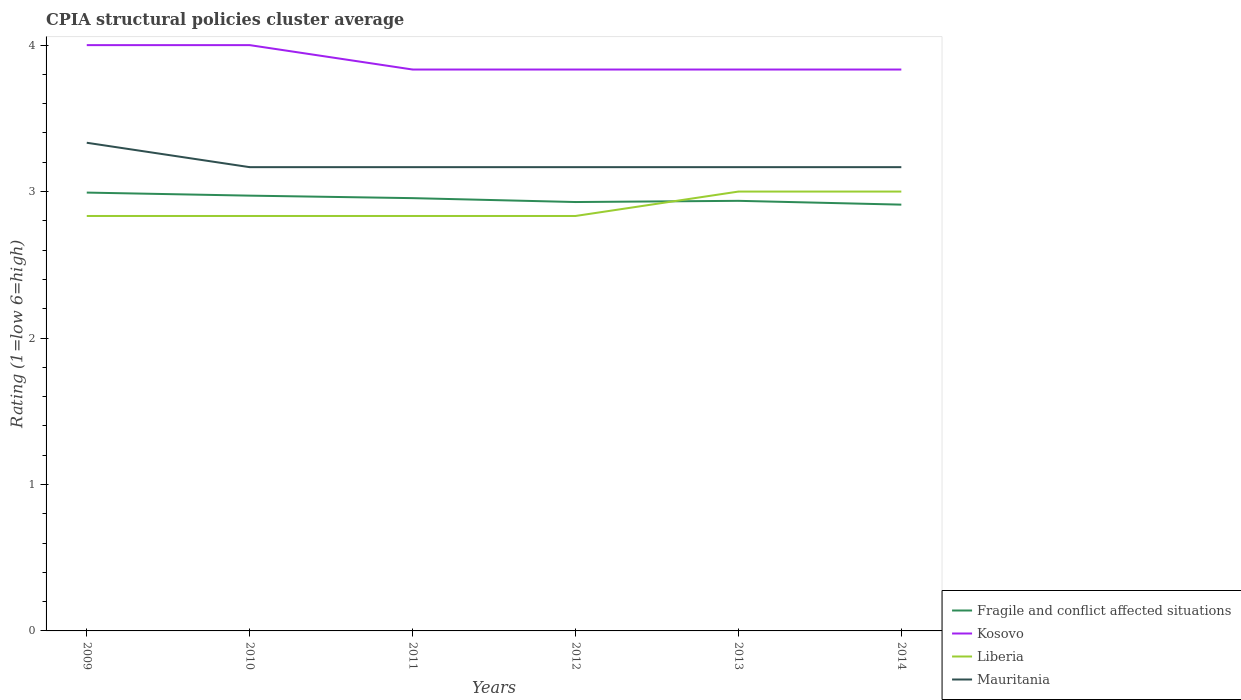How many different coloured lines are there?
Offer a terse response. 4. Does the line corresponding to Fragile and conflict affected situations intersect with the line corresponding to Kosovo?
Ensure brevity in your answer.  No. Is the number of lines equal to the number of legend labels?
Your answer should be compact. Yes. Across all years, what is the maximum CPIA rating in Liberia?
Your response must be concise. 2.83. In which year was the CPIA rating in Kosovo maximum?
Your answer should be compact. 2014. What is the total CPIA rating in Kosovo in the graph?
Keep it short and to the point. 0. What is the difference between the highest and the second highest CPIA rating in Fragile and conflict affected situations?
Offer a terse response. 0.08. What is the difference between the highest and the lowest CPIA rating in Fragile and conflict affected situations?
Provide a succinct answer. 3. Is the CPIA rating in Kosovo strictly greater than the CPIA rating in Fragile and conflict affected situations over the years?
Ensure brevity in your answer.  No. How many lines are there?
Offer a terse response. 4. What is the difference between two consecutive major ticks on the Y-axis?
Offer a terse response. 1. Where does the legend appear in the graph?
Make the answer very short. Bottom right. How are the legend labels stacked?
Give a very brief answer. Vertical. What is the title of the graph?
Offer a terse response. CPIA structural policies cluster average. Does "Low income" appear as one of the legend labels in the graph?
Make the answer very short. No. What is the label or title of the X-axis?
Your answer should be compact. Years. What is the Rating (1=low 6=high) in Fragile and conflict affected situations in 2009?
Make the answer very short. 2.99. What is the Rating (1=low 6=high) in Liberia in 2009?
Give a very brief answer. 2.83. What is the Rating (1=low 6=high) in Mauritania in 2009?
Keep it short and to the point. 3.33. What is the Rating (1=low 6=high) in Fragile and conflict affected situations in 2010?
Offer a very short reply. 2.97. What is the Rating (1=low 6=high) in Kosovo in 2010?
Provide a succinct answer. 4. What is the Rating (1=low 6=high) of Liberia in 2010?
Your response must be concise. 2.83. What is the Rating (1=low 6=high) of Mauritania in 2010?
Give a very brief answer. 3.17. What is the Rating (1=low 6=high) in Fragile and conflict affected situations in 2011?
Your answer should be compact. 2.96. What is the Rating (1=low 6=high) in Kosovo in 2011?
Give a very brief answer. 3.83. What is the Rating (1=low 6=high) of Liberia in 2011?
Your response must be concise. 2.83. What is the Rating (1=low 6=high) of Mauritania in 2011?
Make the answer very short. 3.17. What is the Rating (1=low 6=high) of Fragile and conflict affected situations in 2012?
Your response must be concise. 2.93. What is the Rating (1=low 6=high) of Kosovo in 2012?
Make the answer very short. 3.83. What is the Rating (1=low 6=high) in Liberia in 2012?
Your answer should be very brief. 2.83. What is the Rating (1=low 6=high) in Mauritania in 2012?
Ensure brevity in your answer.  3.17. What is the Rating (1=low 6=high) of Fragile and conflict affected situations in 2013?
Keep it short and to the point. 2.94. What is the Rating (1=low 6=high) of Kosovo in 2013?
Offer a very short reply. 3.83. What is the Rating (1=low 6=high) of Liberia in 2013?
Your answer should be very brief. 3. What is the Rating (1=low 6=high) of Mauritania in 2013?
Keep it short and to the point. 3.17. What is the Rating (1=low 6=high) of Fragile and conflict affected situations in 2014?
Keep it short and to the point. 2.91. What is the Rating (1=low 6=high) of Kosovo in 2014?
Make the answer very short. 3.83. What is the Rating (1=low 6=high) of Liberia in 2014?
Provide a short and direct response. 3. What is the Rating (1=low 6=high) of Mauritania in 2014?
Keep it short and to the point. 3.17. Across all years, what is the maximum Rating (1=low 6=high) of Fragile and conflict affected situations?
Your answer should be very brief. 2.99. Across all years, what is the maximum Rating (1=low 6=high) in Kosovo?
Offer a terse response. 4. Across all years, what is the maximum Rating (1=low 6=high) in Liberia?
Provide a succinct answer. 3. Across all years, what is the maximum Rating (1=low 6=high) in Mauritania?
Keep it short and to the point. 3.33. Across all years, what is the minimum Rating (1=low 6=high) in Fragile and conflict affected situations?
Provide a short and direct response. 2.91. Across all years, what is the minimum Rating (1=low 6=high) of Kosovo?
Your response must be concise. 3.83. Across all years, what is the minimum Rating (1=low 6=high) of Liberia?
Offer a terse response. 2.83. Across all years, what is the minimum Rating (1=low 6=high) in Mauritania?
Provide a succinct answer. 3.17. What is the total Rating (1=low 6=high) of Fragile and conflict affected situations in the graph?
Provide a succinct answer. 17.7. What is the total Rating (1=low 6=high) in Kosovo in the graph?
Offer a very short reply. 23.33. What is the total Rating (1=low 6=high) of Liberia in the graph?
Your answer should be compact. 17.33. What is the total Rating (1=low 6=high) of Mauritania in the graph?
Your answer should be compact. 19.17. What is the difference between the Rating (1=low 6=high) of Fragile and conflict affected situations in 2009 and that in 2010?
Offer a very short reply. 0.02. What is the difference between the Rating (1=low 6=high) in Mauritania in 2009 and that in 2010?
Ensure brevity in your answer.  0.17. What is the difference between the Rating (1=low 6=high) in Fragile and conflict affected situations in 2009 and that in 2011?
Keep it short and to the point. 0.04. What is the difference between the Rating (1=low 6=high) of Kosovo in 2009 and that in 2011?
Offer a very short reply. 0.17. What is the difference between the Rating (1=low 6=high) of Liberia in 2009 and that in 2011?
Give a very brief answer. 0. What is the difference between the Rating (1=low 6=high) of Mauritania in 2009 and that in 2011?
Give a very brief answer. 0.17. What is the difference between the Rating (1=low 6=high) of Fragile and conflict affected situations in 2009 and that in 2012?
Keep it short and to the point. 0.06. What is the difference between the Rating (1=low 6=high) of Fragile and conflict affected situations in 2009 and that in 2013?
Keep it short and to the point. 0.06. What is the difference between the Rating (1=low 6=high) of Kosovo in 2009 and that in 2013?
Ensure brevity in your answer.  0.17. What is the difference between the Rating (1=low 6=high) in Fragile and conflict affected situations in 2009 and that in 2014?
Ensure brevity in your answer.  0.08. What is the difference between the Rating (1=low 6=high) of Mauritania in 2009 and that in 2014?
Provide a short and direct response. 0.17. What is the difference between the Rating (1=low 6=high) in Fragile and conflict affected situations in 2010 and that in 2011?
Provide a short and direct response. 0.02. What is the difference between the Rating (1=low 6=high) in Kosovo in 2010 and that in 2011?
Make the answer very short. 0.17. What is the difference between the Rating (1=low 6=high) in Mauritania in 2010 and that in 2011?
Give a very brief answer. 0. What is the difference between the Rating (1=low 6=high) of Fragile and conflict affected situations in 2010 and that in 2012?
Provide a succinct answer. 0.04. What is the difference between the Rating (1=low 6=high) of Kosovo in 2010 and that in 2012?
Your answer should be very brief. 0.17. What is the difference between the Rating (1=low 6=high) in Liberia in 2010 and that in 2012?
Provide a succinct answer. 0. What is the difference between the Rating (1=low 6=high) in Mauritania in 2010 and that in 2012?
Offer a very short reply. 0. What is the difference between the Rating (1=low 6=high) in Fragile and conflict affected situations in 2010 and that in 2013?
Give a very brief answer. 0.04. What is the difference between the Rating (1=low 6=high) of Liberia in 2010 and that in 2013?
Your answer should be very brief. -0.17. What is the difference between the Rating (1=low 6=high) in Mauritania in 2010 and that in 2013?
Ensure brevity in your answer.  0. What is the difference between the Rating (1=low 6=high) in Fragile and conflict affected situations in 2010 and that in 2014?
Provide a short and direct response. 0.06. What is the difference between the Rating (1=low 6=high) of Mauritania in 2010 and that in 2014?
Your response must be concise. 0. What is the difference between the Rating (1=low 6=high) in Fragile and conflict affected situations in 2011 and that in 2012?
Your answer should be very brief. 0.03. What is the difference between the Rating (1=low 6=high) in Fragile and conflict affected situations in 2011 and that in 2013?
Your answer should be compact. 0.02. What is the difference between the Rating (1=low 6=high) of Kosovo in 2011 and that in 2013?
Your answer should be very brief. 0. What is the difference between the Rating (1=low 6=high) of Liberia in 2011 and that in 2013?
Make the answer very short. -0.17. What is the difference between the Rating (1=low 6=high) in Fragile and conflict affected situations in 2011 and that in 2014?
Give a very brief answer. 0.04. What is the difference between the Rating (1=low 6=high) of Kosovo in 2011 and that in 2014?
Offer a very short reply. 0. What is the difference between the Rating (1=low 6=high) in Fragile and conflict affected situations in 2012 and that in 2013?
Give a very brief answer. -0.01. What is the difference between the Rating (1=low 6=high) of Liberia in 2012 and that in 2013?
Ensure brevity in your answer.  -0.17. What is the difference between the Rating (1=low 6=high) of Mauritania in 2012 and that in 2013?
Give a very brief answer. 0. What is the difference between the Rating (1=low 6=high) of Fragile and conflict affected situations in 2012 and that in 2014?
Make the answer very short. 0.02. What is the difference between the Rating (1=low 6=high) of Fragile and conflict affected situations in 2013 and that in 2014?
Offer a terse response. 0.03. What is the difference between the Rating (1=low 6=high) in Liberia in 2013 and that in 2014?
Give a very brief answer. 0. What is the difference between the Rating (1=low 6=high) of Mauritania in 2013 and that in 2014?
Provide a short and direct response. 0. What is the difference between the Rating (1=low 6=high) in Fragile and conflict affected situations in 2009 and the Rating (1=low 6=high) in Kosovo in 2010?
Provide a succinct answer. -1.01. What is the difference between the Rating (1=low 6=high) in Fragile and conflict affected situations in 2009 and the Rating (1=low 6=high) in Liberia in 2010?
Make the answer very short. 0.16. What is the difference between the Rating (1=low 6=high) in Fragile and conflict affected situations in 2009 and the Rating (1=low 6=high) in Mauritania in 2010?
Your response must be concise. -0.17. What is the difference between the Rating (1=low 6=high) in Kosovo in 2009 and the Rating (1=low 6=high) in Mauritania in 2010?
Provide a short and direct response. 0.83. What is the difference between the Rating (1=low 6=high) in Fragile and conflict affected situations in 2009 and the Rating (1=low 6=high) in Kosovo in 2011?
Offer a terse response. -0.84. What is the difference between the Rating (1=low 6=high) of Fragile and conflict affected situations in 2009 and the Rating (1=low 6=high) of Liberia in 2011?
Provide a succinct answer. 0.16. What is the difference between the Rating (1=low 6=high) in Fragile and conflict affected situations in 2009 and the Rating (1=low 6=high) in Mauritania in 2011?
Give a very brief answer. -0.17. What is the difference between the Rating (1=low 6=high) in Kosovo in 2009 and the Rating (1=low 6=high) in Liberia in 2011?
Your answer should be compact. 1.17. What is the difference between the Rating (1=low 6=high) in Liberia in 2009 and the Rating (1=low 6=high) in Mauritania in 2011?
Keep it short and to the point. -0.33. What is the difference between the Rating (1=low 6=high) in Fragile and conflict affected situations in 2009 and the Rating (1=low 6=high) in Kosovo in 2012?
Offer a terse response. -0.84. What is the difference between the Rating (1=low 6=high) of Fragile and conflict affected situations in 2009 and the Rating (1=low 6=high) of Liberia in 2012?
Your response must be concise. 0.16. What is the difference between the Rating (1=low 6=high) of Fragile and conflict affected situations in 2009 and the Rating (1=low 6=high) of Mauritania in 2012?
Provide a succinct answer. -0.17. What is the difference between the Rating (1=low 6=high) in Kosovo in 2009 and the Rating (1=low 6=high) in Mauritania in 2012?
Keep it short and to the point. 0.83. What is the difference between the Rating (1=low 6=high) in Fragile and conflict affected situations in 2009 and the Rating (1=low 6=high) in Kosovo in 2013?
Give a very brief answer. -0.84. What is the difference between the Rating (1=low 6=high) of Fragile and conflict affected situations in 2009 and the Rating (1=low 6=high) of Liberia in 2013?
Offer a very short reply. -0.01. What is the difference between the Rating (1=low 6=high) in Fragile and conflict affected situations in 2009 and the Rating (1=low 6=high) in Mauritania in 2013?
Give a very brief answer. -0.17. What is the difference between the Rating (1=low 6=high) in Kosovo in 2009 and the Rating (1=low 6=high) in Mauritania in 2013?
Your answer should be very brief. 0.83. What is the difference between the Rating (1=low 6=high) in Liberia in 2009 and the Rating (1=low 6=high) in Mauritania in 2013?
Provide a short and direct response. -0.33. What is the difference between the Rating (1=low 6=high) of Fragile and conflict affected situations in 2009 and the Rating (1=low 6=high) of Kosovo in 2014?
Provide a short and direct response. -0.84. What is the difference between the Rating (1=low 6=high) of Fragile and conflict affected situations in 2009 and the Rating (1=low 6=high) of Liberia in 2014?
Give a very brief answer. -0.01. What is the difference between the Rating (1=low 6=high) of Fragile and conflict affected situations in 2009 and the Rating (1=low 6=high) of Mauritania in 2014?
Give a very brief answer. -0.17. What is the difference between the Rating (1=low 6=high) of Fragile and conflict affected situations in 2010 and the Rating (1=low 6=high) of Kosovo in 2011?
Your answer should be very brief. -0.86. What is the difference between the Rating (1=low 6=high) in Fragile and conflict affected situations in 2010 and the Rating (1=low 6=high) in Liberia in 2011?
Give a very brief answer. 0.14. What is the difference between the Rating (1=low 6=high) in Fragile and conflict affected situations in 2010 and the Rating (1=low 6=high) in Mauritania in 2011?
Offer a terse response. -0.19. What is the difference between the Rating (1=low 6=high) in Fragile and conflict affected situations in 2010 and the Rating (1=low 6=high) in Kosovo in 2012?
Ensure brevity in your answer.  -0.86. What is the difference between the Rating (1=low 6=high) in Fragile and conflict affected situations in 2010 and the Rating (1=low 6=high) in Liberia in 2012?
Give a very brief answer. 0.14. What is the difference between the Rating (1=low 6=high) in Fragile and conflict affected situations in 2010 and the Rating (1=low 6=high) in Mauritania in 2012?
Your response must be concise. -0.19. What is the difference between the Rating (1=low 6=high) of Kosovo in 2010 and the Rating (1=low 6=high) of Mauritania in 2012?
Give a very brief answer. 0.83. What is the difference between the Rating (1=low 6=high) in Liberia in 2010 and the Rating (1=low 6=high) in Mauritania in 2012?
Your answer should be compact. -0.33. What is the difference between the Rating (1=low 6=high) in Fragile and conflict affected situations in 2010 and the Rating (1=low 6=high) in Kosovo in 2013?
Your response must be concise. -0.86. What is the difference between the Rating (1=low 6=high) of Fragile and conflict affected situations in 2010 and the Rating (1=low 6=high) of Liberia in 2013?
Your response must be concise. -0.03. What is the difference between the Rating (1=low 6=high) in Fragile and conflict affected situations in 2010 and the Rating (1=low 6=high) in Mauritania in 2013?
Keep it short and to the point. -0.19. What is the difference between the Rating (1=low 6=high) in Kosovo in 2010 and the Rating (1=low 6=high) in Liberia in 2013?
Give a very brief answer. 1. What is the difference between the Rating (1=low 6=high) of Liberia in 2010 and the Rating (1=low 6=high) of Mauritania in 2013?
Keep it short and to the point. -0.33. What is the difference between the Rating (1=low 6=high) in Fragile and conflict affected situations in 2010 and the Rating (1=low 6=high) in Kosovo in 2014?
Make the answer very short. -0.86. What is the difference between the Rating (1=low 6=high) of Fragile and conflict affected situations in 2010 and the Rating (1=low 6=high) of Liberia in 2014?
Your answer should be compact. -0.03. What is the difference between the Rating (1=low 6=high) of Fragile and conflict affected situations in 2010 and the Rating (1=low 6=high) of Mauritania in 2014?
Give a very brief answer. -0.19. What is the difference between the Rating (1=low 6=high) of Kosovo in 2010 and the Rating (1=low 6=high) of Mauritania in 2014?
Keep it short and to the point. 0.83. What is the difference between the Rating (1=low 6=high) in Fragile and conflict affected situations in 2011 and the Rating (1=low 6=high) in Kosovo in 2012?
Provide a succinct answer. -0.88. What is the difference between the Rating (1=low 6=high) of Fragile and conflict affected situations in 2011 and the Rating (1=low 6=high) of Liberia in 2012?
Offer a terse response. 0.12. What is the difference between the Rating (1=low 6=high) in Fragile and conflict affected situations in 2011 and the Rating (1=low 6=high) in Mauritania in 2012?
Keep it short and to the point. -0.21. What is the difference between the Rating (1=low 6=high) of Fragile and conflict affected situations in 2011 and the Rating (1=low 6=high) of Kosovo in 2013?
Your answer should be compact. -0.88. What is the difference between the Rating (1=low 6=high) of Fragile and conflict affected situations in 2011 and the Rating (1=low 6=high) of Liberia in 2013?
Offer a terse response. -0.04. What is the difference between the Rating (1=low 6=high) in Fragile and conflict affected situations in 2011 and the Rating (1=low 6=high) in Mauritania in 2013?
Your response must be concise. -0.21. What is the difference between the Rating (1=low 6=high) in Kosovo in 2011 and the Rating (1=low 6=high) in Liberia in 2013?
Your response must be concise. 0.83. What is the difference between the Rating (1=low 6=high) in Fragile and conflict affected situations in 2011 and the Rating (1=low 6=high) in Kosovo in 2014?
Make the answer very short. -0.88. What is the difference between the Rating (1=low 6=high) in Fragile and conflict affected situations in 2011 and the Rating (1=low 6=high) in Liberia in 2014?
Provide a succinct answer. -0.04. What is the difference between the Rating (1=low 6=high) in Fragile and conflict affected situations in 2011 and the Rating (1=low 6=high) in Mauritania in 2014?
Your answer should be compact. -0.21. What is the difference between the Rating (1=low 6=high) in Kosovo in 2011 and the Rating (1=low 6=high) in Liberia in 2014?
Keep it short and to the point. 0.83. What is the difference between the Rating (1=low 6=high) in Fragile and conflict affected situations in 2012 and the Rating (1=low 6=high) in Kosovo in 2013?
Provide a short and direct response. -0.9. What is the difference between the Rating (1=low 6=high) of Fragile and conflict affected situations in 2012 and the Rating (1=low 6=high) of Liberia in 2013?
Provide a succinct answer. -0.07. What is the difference between the Rating (1=low 6=high) in Fragile and conflict affected situations in 2012 and the Rating (1=low 6=high) in Mauritania in 2013?
Keep it short and to the point. -0.24. What is the difference between the Rating (1=low 6=high) of Kosovo in 2012 and the Rating (1=low 6=high) of Liberia in 2013?
Offer a very short reply. 0.83. What is the difference between the Rating (1=low 6=high) of Fragile and conflict affected situations in 2012 and the Rating (1=low 6=high) of Kosovo in 2014?
Keep it short and to the point. -0.9. What is the difference between the Rating (1=low 6=high) of Fragile and conflict affected situations in 2012 and the Rating (1=low 6=high) of Liberia in 2014?
Give a very brief answer. -0.07. What is the difference between the Rating (1=low 6=high) of Fragile and conflict affected situations in 2012 and the Rating (1=low 6=high) of Mauritania in 2014?
Your answer should be very brief. -0.24. What is the difference between the Rating (1=low 6=high) of Kosovo in 2012 and the Rating (1=low 6=high) of Liberia in 2014?
Your answer should be compact. 0.83. What is the difference between the Rating (1=low 6=high) in Fragile and conflict affected situations in 2013 and the Rating (1=low 6=high) in Kosovo in 2014?
Your answer should be very brief. -0.9. What is the difference between the Rating (1=low 6=high) of Fragile and conflict affected situations in 2013 and the Rating (1=low 6=high) of Liberia in 2014?
Provide a short and direct response. -0.06. What is the difference between the Rating (1=low 6=high) in Fragile and conflict affected situations in 2013 and the Rating (1=low 6=high) in Mauritania in 2014?
Make the answer very short. -0.23. What is the difference between the Rating (1=low 6=high) of Kosovo in 2013 and the Rating (1=low 6=high) of Liberia in 2014?
Make the answer very short. 0.83. What is the difference between the Rating (1=low 6=high) of Kosovo in 2013 and the Rating (1=low 6=high) of Mauritania in 2014?
Make the answer very short. 0.67. What is the average Rating (1=low 6=high) of Fragile and conflict affected situations per year?
Keep it short and to the point. 2.95. What is the average Rating (1=low 6=high) in Kosovo per year?
Provide a short and direct response. 3.89. What is the average Rating (1=low 6=high) in Liberia per year?
Keep it short and to the point. 2.89. What is the average Rating (1=low 6=high) of Mauritania per year?
Your answer should be very brief. 3.19. In the year 2009, what is the difference between the Rating (1=low 6=high) of Fragile and conflict affected situations and Rating (1=low 6=high) of Kosovo?
Provide a short and direct response. -1.01. In the year 2009, what is the difference between the Rating (1=low 6=high) in Fragile and conflict affected situations and Rating (1=low 6=high) in Liberia?
Provide a succinct answer. 0.16. In the year 2009, what is the difference between the Rating (1=low 6=high) of Fragile and conflict affected situations and Rating (1=low 6=high) of Mauritania?
Your answer should be compact. -0.34. In the year 2009, what is the difference between the Rating (1=low 6=high) of Kosovo and Rating (1=low 6=high) of Mauritania?
Provide a succinct answer. 0.67. In the year 2010, what is the difference between the Rating (1=low 6=high) of Fragile and conflict affected situations and Rating (1=low 6=high) of Kosovo?
Offer a terse response. -1.03. In the year 2010, what is the difference between the Rating (1=low 6=high) in Fragile and conflict affected situations and Rating (1=low 6=high) in Liberia?
Make the answer very short. 0.14. In the year 2010, what is the difference between the Rating (1=low 6=high) in Fragile and conflict affected situations and Rating (1=low 6=high) in Mauritania?
Offer a terse response. -0.19. In the year 2010, what is the difference between the Rating (1=low 6=high) of Kosovo and Rating (1=low 6=high) of Liberia?
Your response must be concise. 1.17. In the year 2010, what is the difference between the Rating (1=low 6=high) of Kosovo and Rating (1=low 6=high) of Mauritania?
Give a very brief answer. 0.83. In the year 2010, what is the difference between the Rating (1=low 6=high) in Liberia and Rating (1=low 6=high) in Mauritania?
Offer a very short reply. -0.33. In the year 2011, what is the difference between the Rating (1=low 6=high) of Fragile and conflict affected situations and Rating (1=low 6=high) of Kosovo?
Your answer should be very brief. -0.88. In the year 2011, what is the difference between the Rating (1=low 6=high) of Fragile and conflict affected situations and Rating (1=low 6=high) of Liberia?
Give a very brief answer. 0.12. In the year 2011, what is the difference between the Rating (1=low 6=high) of Fragile and conflict affected situations and Rating (1=low 6=high) of Mauritania?
Ensure brevity in your answer.  -0.21. In the year 2011, what is the difference between the Rating (1=low 6=high) of Kosovo and Rating (1=low 6=high) of Liberia?
Ensure brevity in your answer.  1. In the year 2011, what is the difference between the Rating (1=low 6=high) of Liberia and Rating (1=low 6=high) of Mauritania?
Provide a succinct answer. -0.33. In the year 2012, what is the difference between the Rating (1=low 6=high) of Fragile and conflict affected situations and Rating (1=low 6=high) of Kosovo?
Offer a very short reply. -0.9. In the year 2012, what is the difference between the Rating (1=low 6=high) of Fragile and conflict affected situations and Rating (1=low 6=high) of Liberia?
Provide a short and direct response. 0.1. In the year 2012, what is the difference between the Rating (1=low 6=high) in Fragile and conflict affected situations and Rating (1=low 6=high) in Mauritania?
Your answer should be compact. -0.24. In the year 2012, what is the difference between the Rating (1=low 6=high) of Kosovo and Rating (1=low 6=high) of Mauritania?
Offer a very short reply. 0.67. In the year 2013, what is the difference between the Rating (1=low 6=high) in Fragile and conflict affected situations and Rating (1=low 6=high) in Kosovo?
Your response must be concise. -0.9. In the year 2013, what is the difference between the Rating (1=low 6=high) of Fragile and conflict affected situations and Rating (1=low 6=high) of Liberia?
Offer a terse response. -0.06. In the year 2013, what is the difference between the Rating (1=low 6=high) in Fragile and conflict affected situations and Rating (1=low 6=high) in Mauritania?
Ensure brevity in your answer.  -0.23. In the year 2013, what is the difference between the Rating (1=low 6=high) in Kosovo and Rating (1=low 6=high) in Liberia?
Provide a short and direct response. 0.83. In the year 2014, what is the difference between the Rating (1=low 6=high) in Fragile and conflict affected situations and Rating (1=low 6=high) in Kosovo?
Keep it short and to the point. -0.92. In the year 2014, what is the difference between the Rating (1=low 6=high) in Fragile and conflict affected situations and Rating (1=low 6=high) in Liberia?
Your response must be concise. -0.09. In the year 2014, what is the difference between the Rating (1=low 6=high) of Fragile and conflict affected situations and Rating (1=low 6=high) of Mauritania?
Your answer should be very brief. -0.26. In the year 2014, what is the difference between the Rating (1=low 6=high) in Kosovo and Rating (1=low 6=high) in Liberia?
Your answer should be very brief. 0.83. What is the ratio of the Rating (1=low 6=high) of Mauritania in 2009 to that in 2010?
Provide a short and direct response. 1.05. What is the ratio of the Rating (1=low 6=high) of Fragile and conflict affected situations in 2009 to that in 2011?
Your answer should be very brief. 1.01. What is the ratio of the Rating (1=low 6=high) in Kosovo in 2009 to that in 2011?
Give a very brief answer. 1.04. What is the ratio of the Rating (1=low 6=high) of Mauritania in 2009 to that in 2011?
Provide a short and direct response. 1.05. What is the ratio of the Rating (1=low 6=high) of Kosovo in 2009 to that in 2012?
Your answer should be compact. 1.04. What is the ratio of the Rating (1=low 6=high) in Liberia in 2009 to that in 2012?
Provide a short and direct response. 1. What is the ratio of the Rating (1=low 6=high) in Mauritania in 2009 to that in 2012?
Your answer should be compact. 1.05. What is the ratio of the Rating (1=low 6=high) of Fragile and conflict affected situations in 2009 to that in 2013?
Your answer should be very brief. 1.02. What is the ratio of the Rating (1=low 6=high) of Kosovo in 2009 to that in 2013?
Make the answer very short. 1.04. What is the ratio of the Rating (1=low 6=high) in Liberia in 2009 to that in 2013?
Provide a succinct answer. 0.94. What is the ratio of the Rating (1=low 6=high) in Mauritania in 2009 to that in 2013?
Provide a succinct answer. 1.05. What is the ratio of the Rating (1=low 6=high) in Fragile and conflict affected situations in 2009 to that in 2014?
Make the answer very short. 1.03. What is the ratio of the Rating (1=low 6=high) of Kosovo in 2009 to that in 2014?
Your answer should be very brief. 1.04. What is the ratio of the Rating (1=low 6=high) in Mauritania in 2009 to that in 2014?
Ensure brevity in your answer.  1.05. What is the ratio of the Rating (1=low 6=high) in Kosovo in 2010 to that in 2011?
Offer a terse response. 1.04. What is the ratio of the Rating (1=low 6=high) in Fragile and conflict affected situations in 2010 to that in 2012?
Provide a short and direct response. 1.01. What is the ratio of the Rating (1=low 6=high) in Kosovo in 2010 to that in 2012?
Provide a succinct answer. 1.04. What is the ratio of the Rating (1=low 6=high) in Mauritania in 2010 to that in 2012?
Your answer should be compact. 1. What is the ratio of the Rating (1=low 6=high) in Fragile and conflict affected situations in 2010 to that in 2013?
Offer a very short reply. 1.01. What is the ratio of the Rating (1=low 6=high) of Kosovo in 2010 to that in 2013?
Your answer should be very brief. 1.04. What is the ratio of the Rating (1=low 6=high) in Liberia in 2010 to that in 2013?
Ensure brevity in your answer.  0.94. What is the ratio of the Rating (1=low 6=high) of Mauritania in 2010 to that in 2013?
Provide a succinct answer. 1. What is the ratio of the Rating (1=low 6=high) of Fragile and conflict affected situations in 2010 to that in 2014?
Give a very brief answer. 1.02. What is the ratio of the Rating (1=low 6=high) in Kosovo in 2010 to that in 2014?
Ensure brevity in your answer.  1.04. What is the ratio of the Rating (1=low 6=high) in Mauritania in 2010 to that in 2014?
Your response must be concise. 1. What is the ratio of the Rating (1=low 6=high) in Fragile and conflict affected situations in 2011 to that in 2012?
Offer a terse response. 1.01. What is the ratio of the Rating (1=low 6=high) in Kosovo in 2011 to that in 2012?
Provide a succinct answer. 1. What is the ratio of the Rating (1=low 6=high) in Liberia in 2011 to that in 2012?
Your answer should be compact. 1. What is the ratio of the Rating (1=low 6=high) of Mauritania in 2011 to that in 2012?
Give a very brief answer. 1. What is the ratio of the Rating (1=low 6=high) in Kosovo in 2011 to that in 2013?
Offer a terse response. 1. What is the ratio of the Rating (1=low 6=high) in Liberia in 2011 to that in 2013?
Offer a very short reply. 0.94. What is the ratio of the Rating (1=low 6=high) of Fragile and conflict affected situations in 2011 to that in 2014?
Give a very brief answer. 1.02. What is the ratio of the Rating (1=low 6=high) in Kosovo in 2011 to that in 2014?
Your answer should be very brief. 1. What is the ratio of the Rating (1=low 6=high) of Liberia in 2011 to that in 2014?
Your answer should be compact. 0.94. What is the ratio of the Rating (1=low 6=high) in Mauritania in 2012 to that in 2013?
Your answer should be very brief. 1. What is the ratio of the Rating (1=low 6=high) in Kosovo in 2012 to that in 2014?
Make the answer very short. 1. What is the ratio of the Rating (1=low 6=high) of Mauritania in 2012 to that in 2014?
Offer a very short reply. 1. What is the ratio of the Rating (1=low 6=high) in Liberia in 2013 to that in 2014?
Offer a terse response. 1. What is the difference between the highest and the second highest Rating (1=low 6=high) in Fragile and conflict affected situations?
Offer a terse response. 0.02. What is the difference between the highest and the second highest Rating (1=low 6=high) in Kosovo?
Offer a terse response. 0. What is the difference between the highest and the second highest Rating (1=low 6=high) in Liberia?
Provide a succinct answer. 0. What is the difference between the highest and the second highest Rating (1=low 6=high) of Mauritania?
Your response must be concise. 0.17. What is the difference between the highest and the lowest Rating (1=low 6=high) of Fragile and conflict affected situations?
Your answer should be compact. 0.08. What is the difference between the highest and the lowest Rating (1=low 6=high) of Kosovo?
Make the answer very short. 0.17. What is the difference between the highest and the lowest Rating (1=low 6=high) in Mauritania?
Your answer should be very brief. 0.17. 